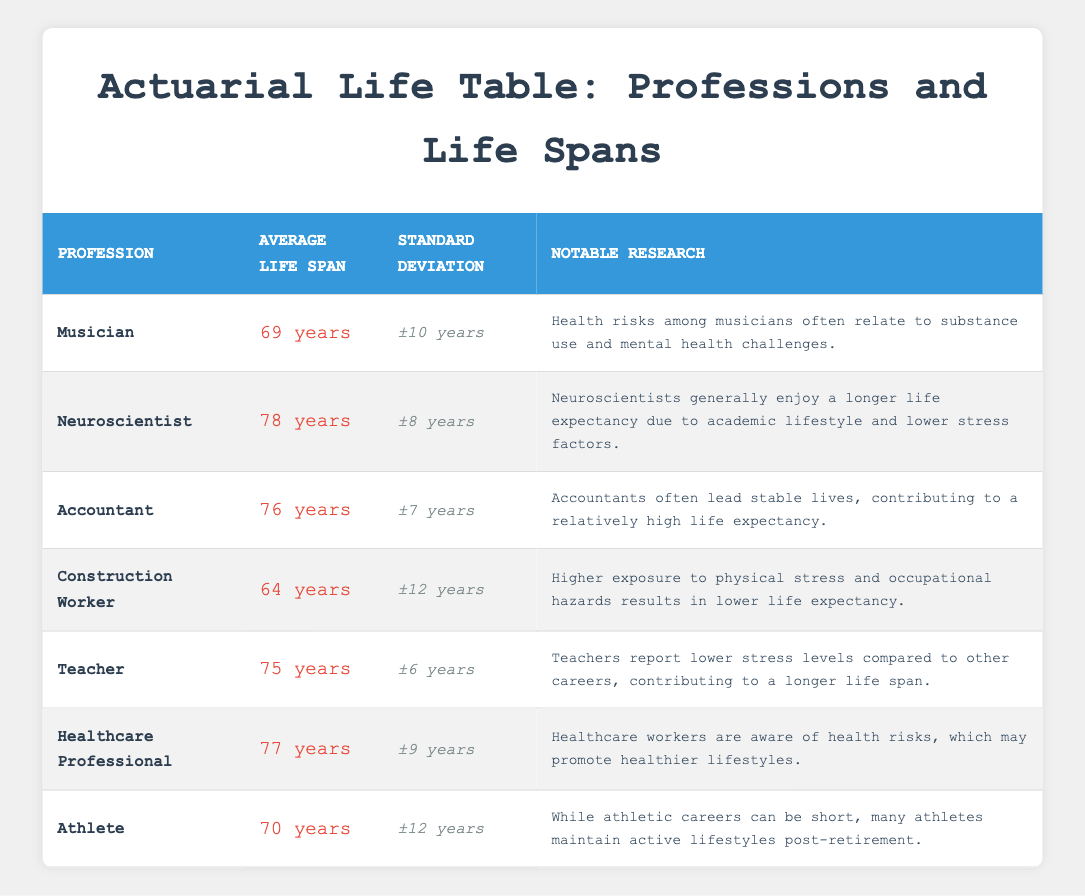What is the average life span of a musician? According to the table, the average life span of a musician is listed directly in the relevant row. It states the average life span for a musician is 69 years.
Answer: 69 years Which profession has the highest average life span? By examining the average life spans across all professions listed in the table, the Neuroscientist has the highest average life span of 78 years.
Answer: Neuroscientist What is the difference in average life span between healthcare professionals and teachers? The average life span of healthcare professionals is 77 years, while that of teachers is 75 years. The difference is calculated as 77 - 75 = 2 years.
Answer: 2 years True or False: Construction workers have a higher average life span than musicians. The average life span of construction workers is 64 years, which is lower than that of musicians at 69 years. Therefore, the statement is false.
Answer: False What is the average life span of an accountant compared to that of an athlete? The average life span of an accountant is 76 years and for athletes, it is 70 years. The accountant lives longer by 76 - 70 = 6 years on average.
Answer: 6 years Is it true that the standard deviation for musicians is higher than that for teachers? The standard deviation for musicians is ±10 years and for teachers, it is ±6 years. Since 10 is greater than 6, the statement is true.
Answer: True Which two professions have a combined average life span above 150 years? The average life spans of musicians (69 years) and healthcare professionals (77 years) sum to 69 + 77 = 146 years. No combinations exceed 150 years, including Accountant (76), which does not pair adequately with any to exceed that threshold.
Answer: No combination exceeds 150 years If a musician lives exactly the average life span mentioned, what is the likely range of life spans considering the standard deviation? The average life span of a musician is 69 years with a standard deviation of ±10 years, implying a likely range of life spans from 69 - 10 = 59 years to 69 + 10 = 79 years.
Answer: 59 to 79 years 